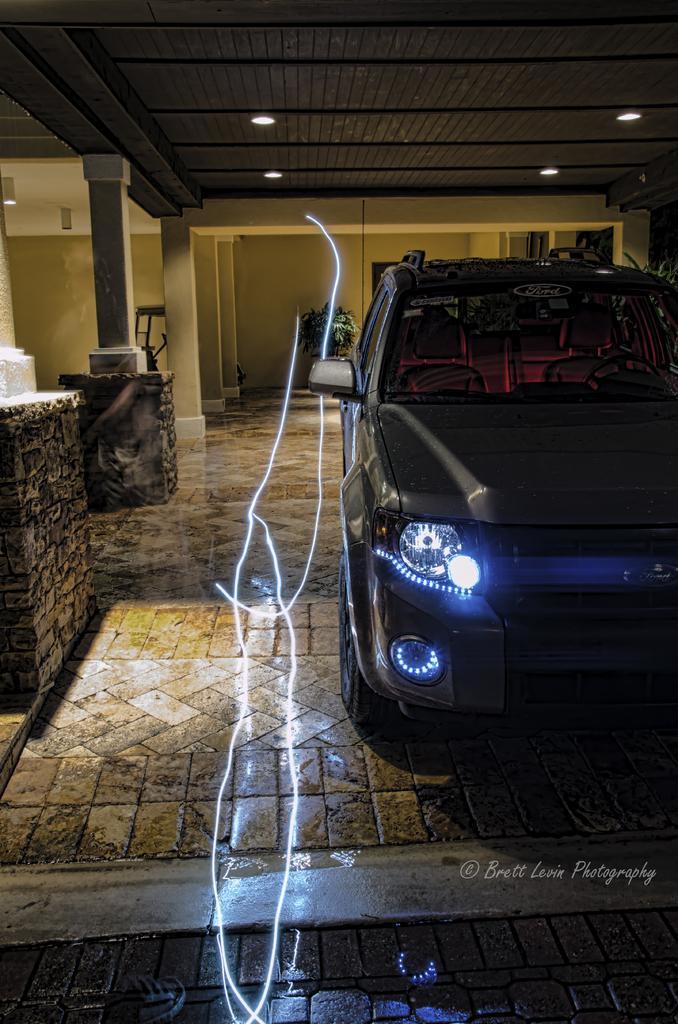How would you summarize this image in a sentence or two? In this image there is a floor in the bottom of this image and there is a car on the right side of this image. There is a wall in the background. There are some lights arranged on the top of this image. 